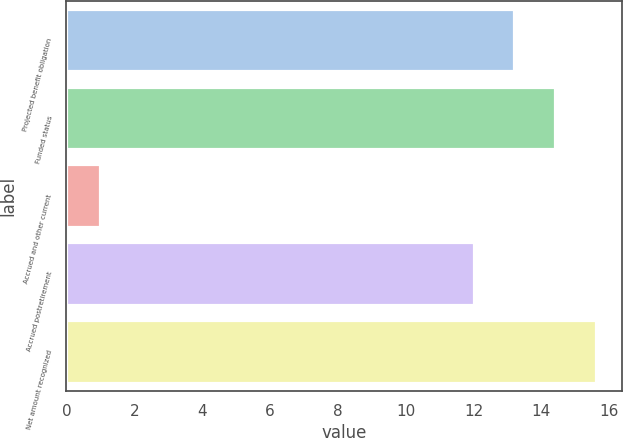<chart> <loc_0><loc_0><loc_500><loc_500><bar_chart><fcel>Projected benefit obligation<fcel>Funded status<fcel>Accrued and other current<fcel>Accrued postretirement<fcel>Net amount recognized<nl><fcel>13.2<fcel>14.4<fcel>1<fcel>12<fcel>15.6<nl></chart> 